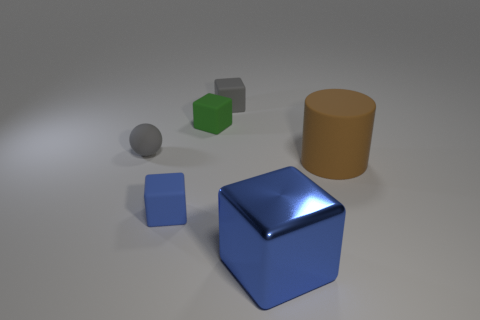Add 4 green rubber blocks. How many objects exist? 10 Subtract all blocks. How many objects are left? 2 Subtract all brown cylinders. Subtract all large things. How many objects are left? 3 Add 1 blue shiny cubes. How many blue shiny cubes are left? 2 Add 1 small red shiny objects. How many small red shiny objects exist? 1 Subtract 0 green cylinders. How many objects are left? 6 